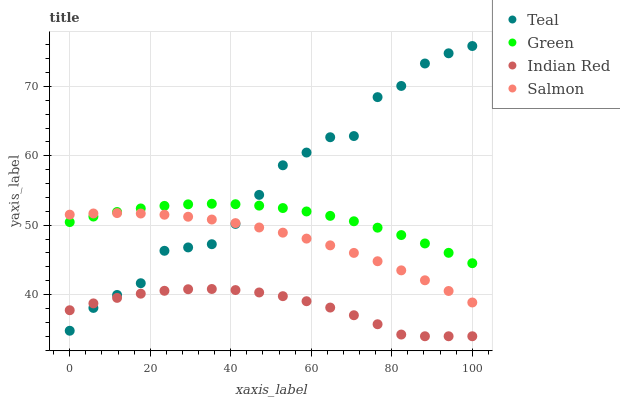Does Indian Red have the minimum area under the curve?
Answer yes or no. Yes. Does Teal have the maximum area under the curve?
Answer yes or no. Yes. Does Green have the minimum area under the curve?
Answer yes or no. No. Does Green have the maximum area under the curve?
Answer yes or no. No. Is Salmon the smoothest?
Answer yes or no. Yes. Is Teal the roughest?
Answer yes or no. Yes. Is Green the smoothest?
Answer yes or no. No. Is Green the roughest?
Answer yes or no. No. Does Indian Red have the lowest value?
Answer yes or no. Yes. Does Green have the lowest value?
Answer yes or no. No. Does Teal have the highest value?
Answer yes or no. Yes. Does Green have the highest value?
Answer yes or no. No. Is Indian Red less than Salmon?
Answer yes or no. Yes. Is Green greater than Indian Red?
Answer yes or no. Yes. Does Teal intersect Salmon?
Answer yes or no. Yes. Is Teal less than Salmon?
Answer yes or no. No. Is Teal greater than Salmon?
Answer yes or no. No. Does Indian Red intersect Salmon?
Answer yes or no. No. 